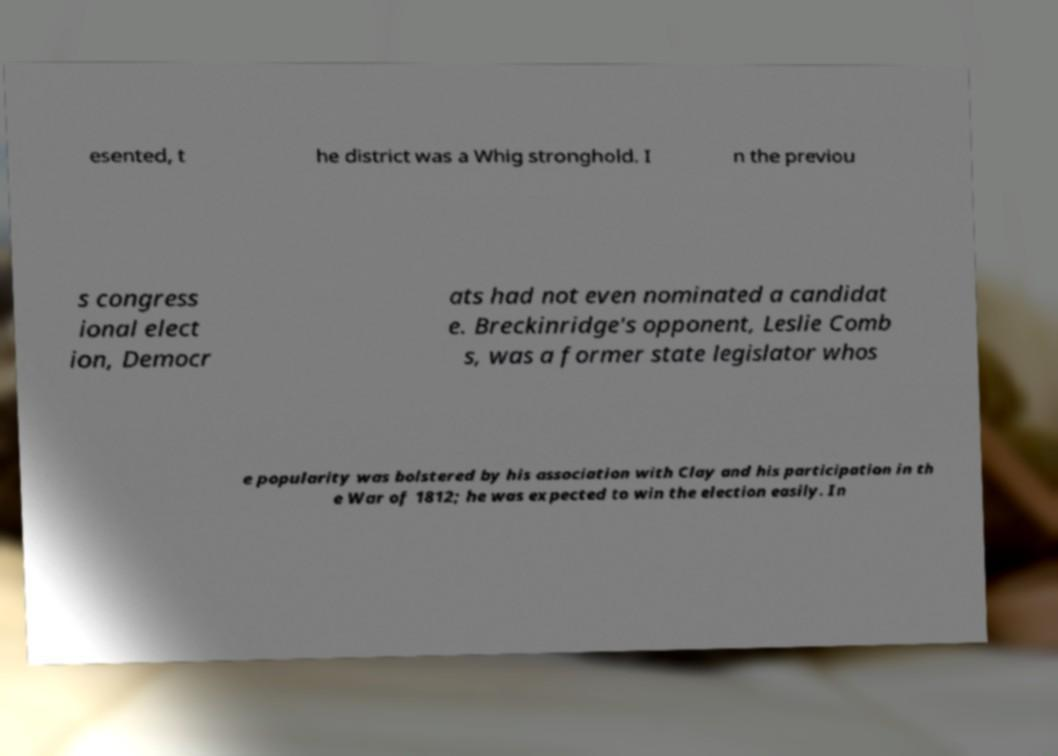Could you assist in decoding the text presented in this image and type it out clearly? esented, t he district was a Whig stronghold. I n the previou s congress ional elect ion, Democr ats had not even nominated a candidat e. Breckinridge's opponent, Leslie Comb s, was a former state legislator whos e popularity was bolstered by his association with Clay and his participation in th e War of 1812; he was expected to win the election easily. In 